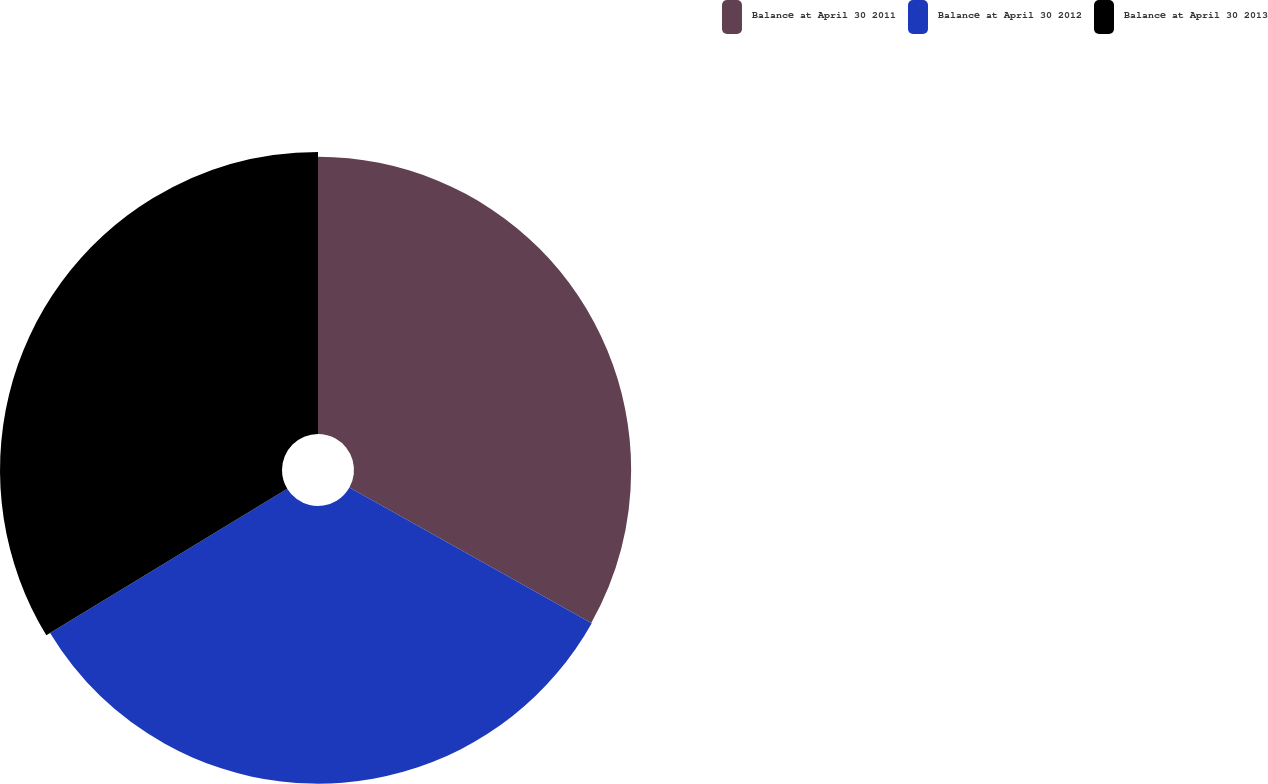<chart> <loc_0><loc_0><loc_500><loc_500><pie_chart><fcel>Balance at April 30 2011<fcel>Balance at April 30 2012<fcel>Balance at April 30 2013<nl><fcel>33.12%<fcel>33.18%<fcel>33.7%<nl></chart> 